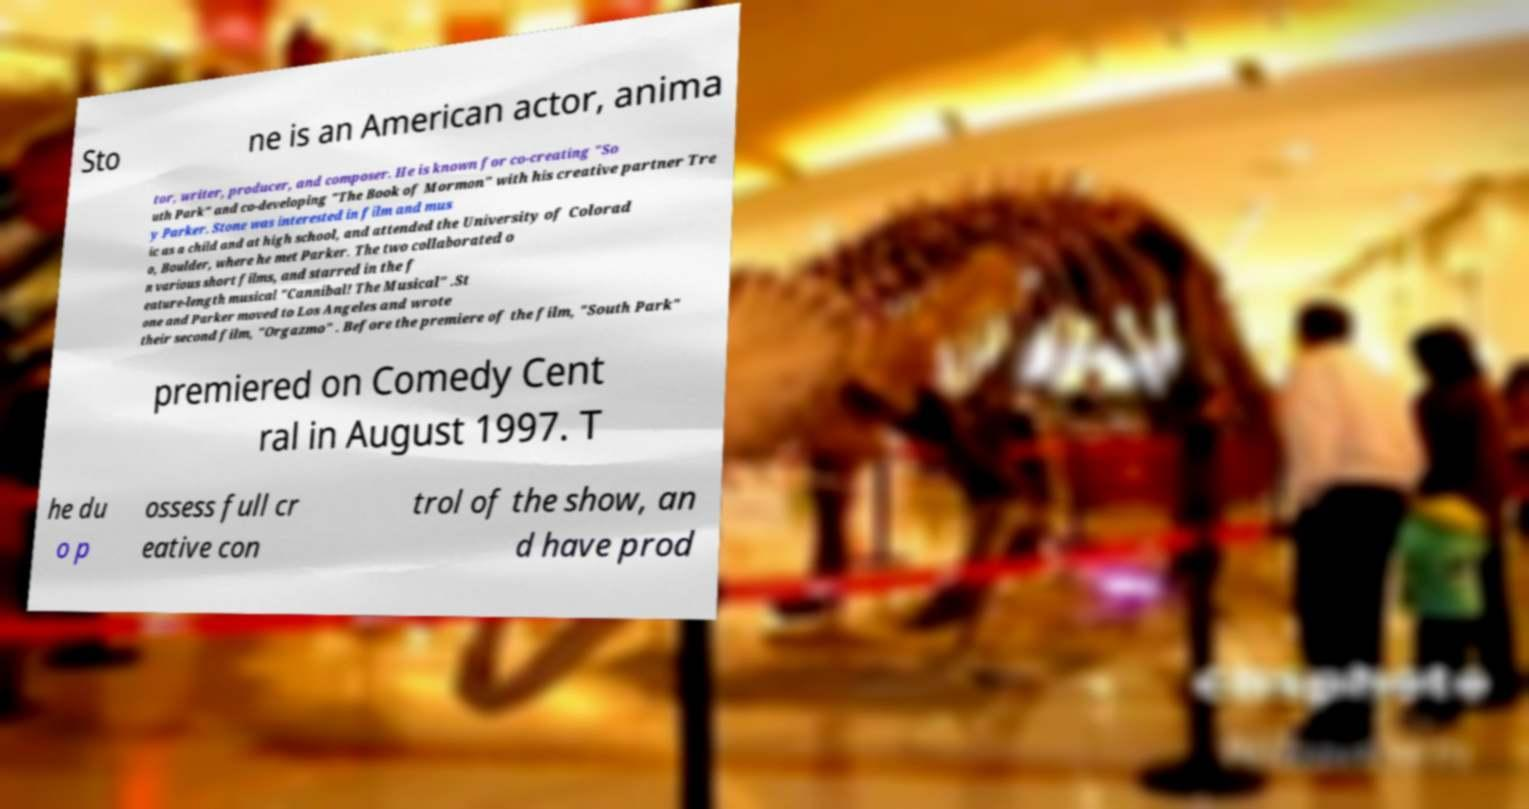What messages or text are displayed in this image? I need them in a readable, typed format. Sto ne is an American actor, anima tor, writer, producer, and composer. He is known for co-creating "So uth Park" and co-developing "The Book of Mormon" with his creative partner Tre y Parker. Stone was interested in film and mus ic as a child and at high school, and attended the University of Colorad o, Boulder, where he met Parker. The two collaborated o n various short films, and starred in the f eature-length musical "Cannibal! The Musical" .St one and Parker moved to Los Angeles and wrote their second film, "Orgazmo" . Before the premiere of the film, "South Park" premiered on Comedy Cent ral in August 1997. T he du o p ossess full cr eative con trol of the show, an d have prod 